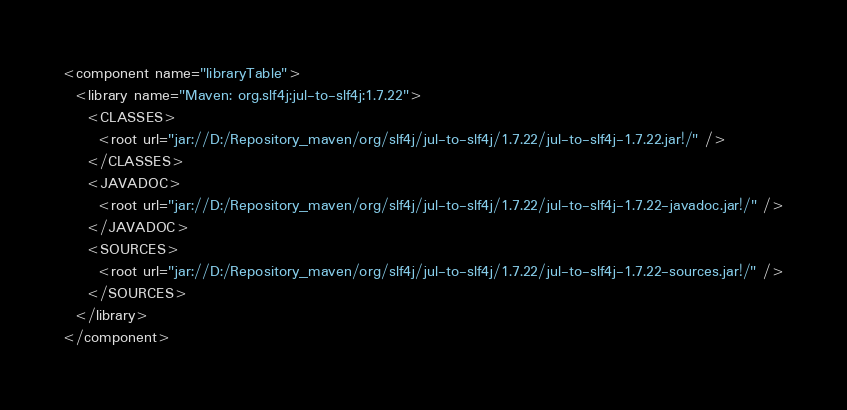<code> <loc_0><loc_0><loc_500><loc_500><_XML_><component name="libraryTable">
  <library name="Maven: org.slf4j:jul-to-slf4j:1.7.22">
    <CLASSES>
      <root url="jar://D:/Repository_maven/org/slf4j/jul-to-slf4j/1.7.22/jul-to-slf4j-1.7.22.jar!/" />
    </CLASSES>
    <JAVADOC>
      <root url="jar://D:/Repository_maven/org/slf4j/jul-to-slf4j/1.7.22/jul-to-slf4j-1.7.22-javadoc.jar!/" />
    </JAVADOC>
    <SOURCES>
      <root url="jar://D:/Repository_maven/org/slf4j/jul-to-slf4j/1.7.22/jul-to-slf4j-1.7.22-sources.jar!/" />
    </SOURCES>
  </library>
</component></code> 